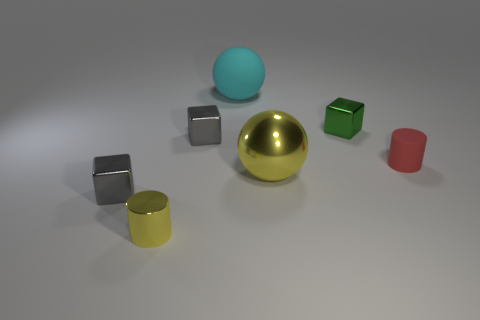How many big spheres have the same color as the metal cylinder?
Give a very brief answer. 1. Is the color of the tiny cylinder that is left of the big metallic thing the same as the big shiny ball?
Offer a very short reply. Yes. There is a gray shiny block that is in front of the gray shiny thing right of the small gray metal object in front of the small red thing; what size is it?
Ensure brevity in your answer.  Small. The green object that is the same size as the red object is what shape?
Keep it short and to the point. Cube. What is the shape of the small yellow thing?
Offer a terse response. Cylinder. Is the material of the big sphere behind the small green metallic block the same as the red cylinder?
Make the answer very short. Yes. What size is the object behind the green cube on the left side of the tiny red cylinder?
Offer a terse response. Large. What is the color of the tiny shiny thing that is both in front of the green metal block and behind the matte cylinder?
Give a very brief answer. Gray. There is a ball that is the same size as the cyan matte object; what material is it?
Give a very brief answer. Metal. How many other objects are there of the same material as the big cyan ball?
Give a very brief answer. 1. 